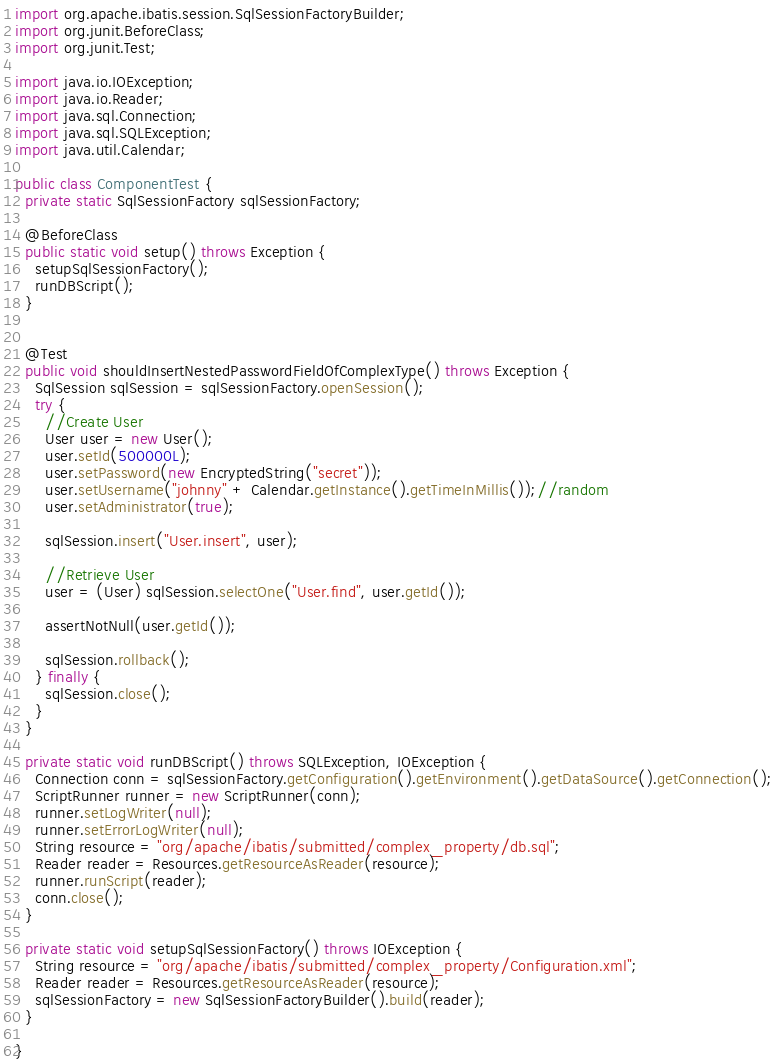<code> <loc_0><loc_0><loc_500><loc_500><_Java_>import org.apache.ibatis.session.SqlSessionFactoryBuilder;
import org.junit.BeforeClass;
import org.junit.Test;

import java.io.IOException;
import java.io.Reader;
import java.sql.Connection;
import java.sql.SQLException;
import java.util.Calendar;

public class ComponentTest {
  private static SqlSessionFactory sqlSessionFactory;

  @BeforeClass
  public static void setup() throws Exception {
    setupSqlSessionFactory();
    runDBScript();
  }


  @Test
  public void shouldInsertNestedPasswordFieldOfComplexType() throws Exception {
    SqlSession sqlSession = sqlSessionFactory.openSession();
    try {
      //Create User
      User user = new User();
      user.setId(500000L);
      user.setPassword(new EncryptedString("secret"));
      user.setUsername("johnny" + Calendar.getInstance().getTimeInMillis());//random
      user.setAdministrator(true);

      sqlSession.insert("User.insert", user);

      //Retrieve User
      user = (User) sqlSession.selectOne("User.find", user.getId());

      assertNotNull(user.getId());

      sqlSession.rollback();
    } finally {
      sqlSession.close();
    }
  }

  private static void runDBScript() throws SQLException, IOException {
    Connection conn = sqlSessionFactory.getConfiguration().getEnvironment().getDataSource().getConnection();
    ScriptRunner runner = new ScriptRunner(conn);
    runner.setLogWriter(null);
    runner.setErrorLogWriter(null);
    String resource = "org/apache/ibatis/submitted/complex_property/db.sql";
    Reader reader = Resources.getResourceAsReader(resource);
    runner.runScript(reader);
    conn.close();
  }

  private static void setupSqlSessionFactory() throws IOException {
    String resource = "org/apache/ibatis/submitted/complex_property/Configuration.xml";
    Reader reader = Resources.getResourceAsReader(resource);
    sqlSessionFactory = new SqlSessionFactoryBuilder().build(reader);
  }

}
</code> 